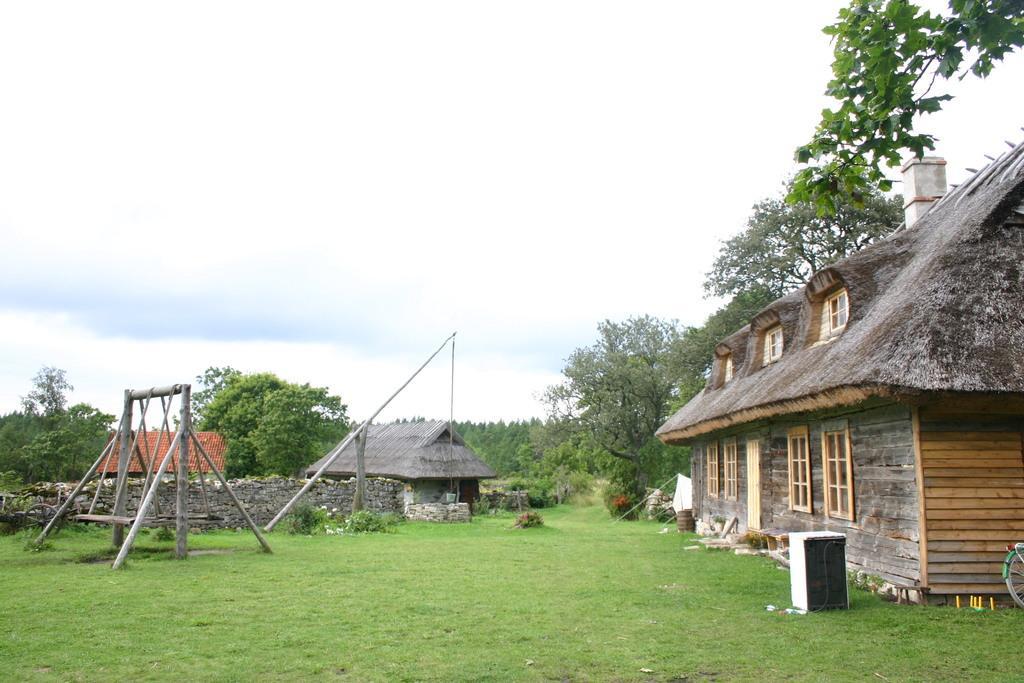Describe this image in one or two sentences. In this image there are sheds. On the left we can see a swing. In the background there are trees and sky. 